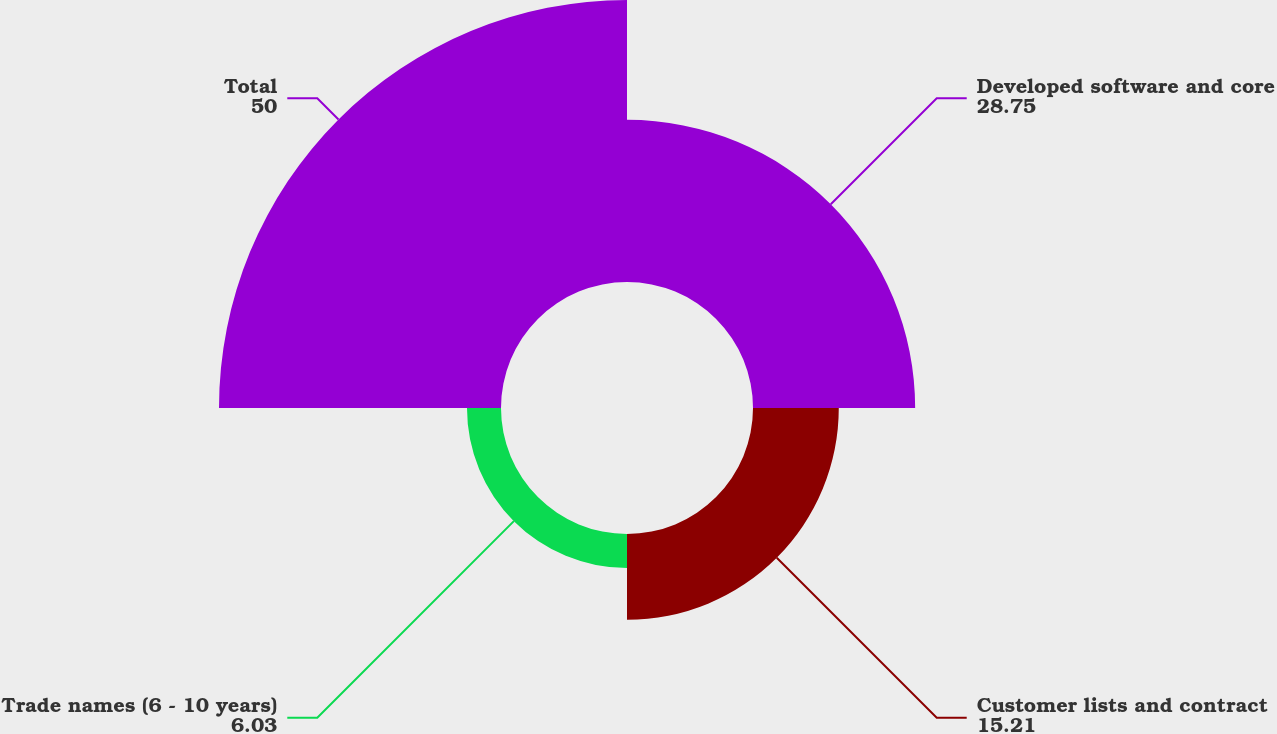Convert chart to OTSL. <chart><loc_0><loc_0><loc_500><loc_500><pie_chart><fcel>Developed software and core<fcel>Customer lists and contract<fcel>Trade names (6 - 10 years)<fcel>Total<nl><fcel>28.75%<fcel>15.21%<fcel>6.03%<fcel>50.0%<nl></chart> 